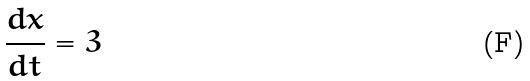<formula> <loc_0><loc_0><loc_500><loc_500>\frac { d x } { d t } = 3</formula> 